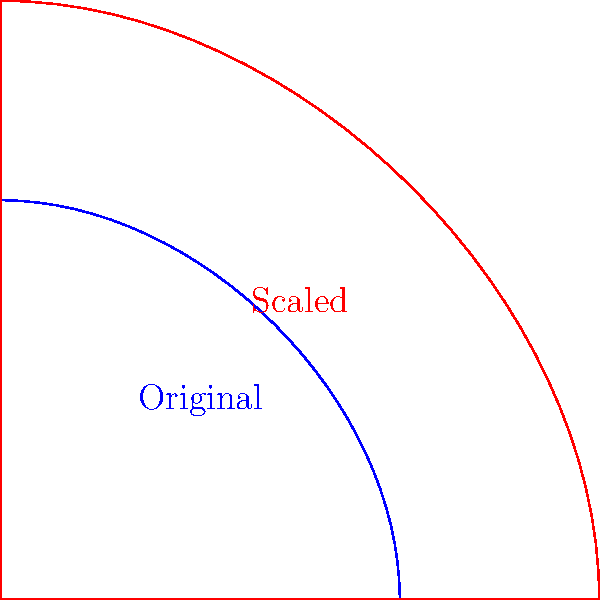In cinematography, a director wants to create a more expansive view of a scene by scaling up the camera lens diagram. If the original lens diagram has a height of 2 units and is scaled by a factor of 1.5, what is the new height of the lens diagram? How does this transformation relate to the concept of dilation in filmmaking, and what ethical considerations might arise from manipulating visual perspective in crime fiction? To solve this problem, we'll follow these steps:

1. Identify the original height: The original lens diagram has a height of 2 units.

2. Apply the scaling factor: The lens is being scaled by a factor of 1.5.

3. Calculate the new height: 
   $$ \text{New Height} = \text{Original Height} \times \text{Scaling Factor} $$
   $$ \text{New Height} = 2 \times 1.5 = 3 \text{ units} $$

4. Understand dilation in filmmaking:
   Dilation in cinematography refers to the expansion or contraction of visual elements. In this case, scaling up the lens diagram represents a dilation that would result in a wider field of view, capturing more of the scene.

5. Ethical considerations in crime fiction:
   a) Manipulating visual perspective through dilation can potentially exaggerate or minimize the impact of violent scenes.
   b) Expanded views might provide more context but could also increase the graphic nature of crime depictions.
   c) Altering perspective raises questions about authenticity and responsible representation of criminal activities.

The transformation demonstrates how filmmakers can use geometric principles to influence audience perception, potentially glorifying or sensationalizing violence in crime fiction.
Answer: 3 units; dilation expands the field of view, raising ethical concerns about violence representation in crime fiction. 